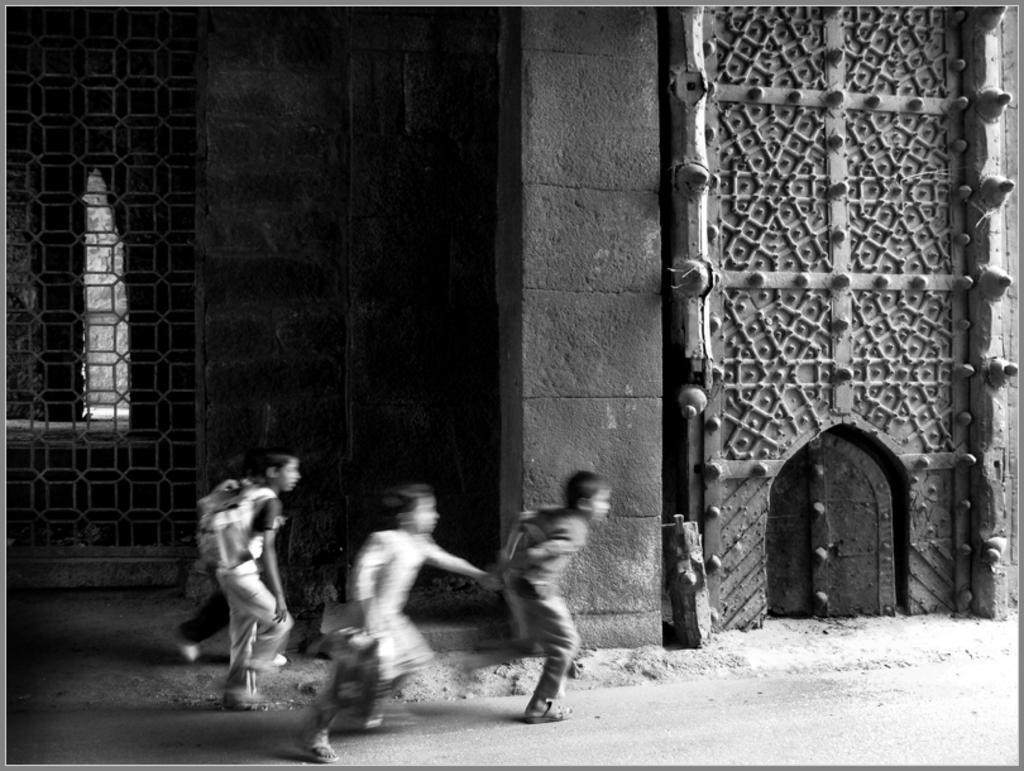How would you summarize this image in a sentence or two? In this image, we can see kids running and in the background, there is a building. 